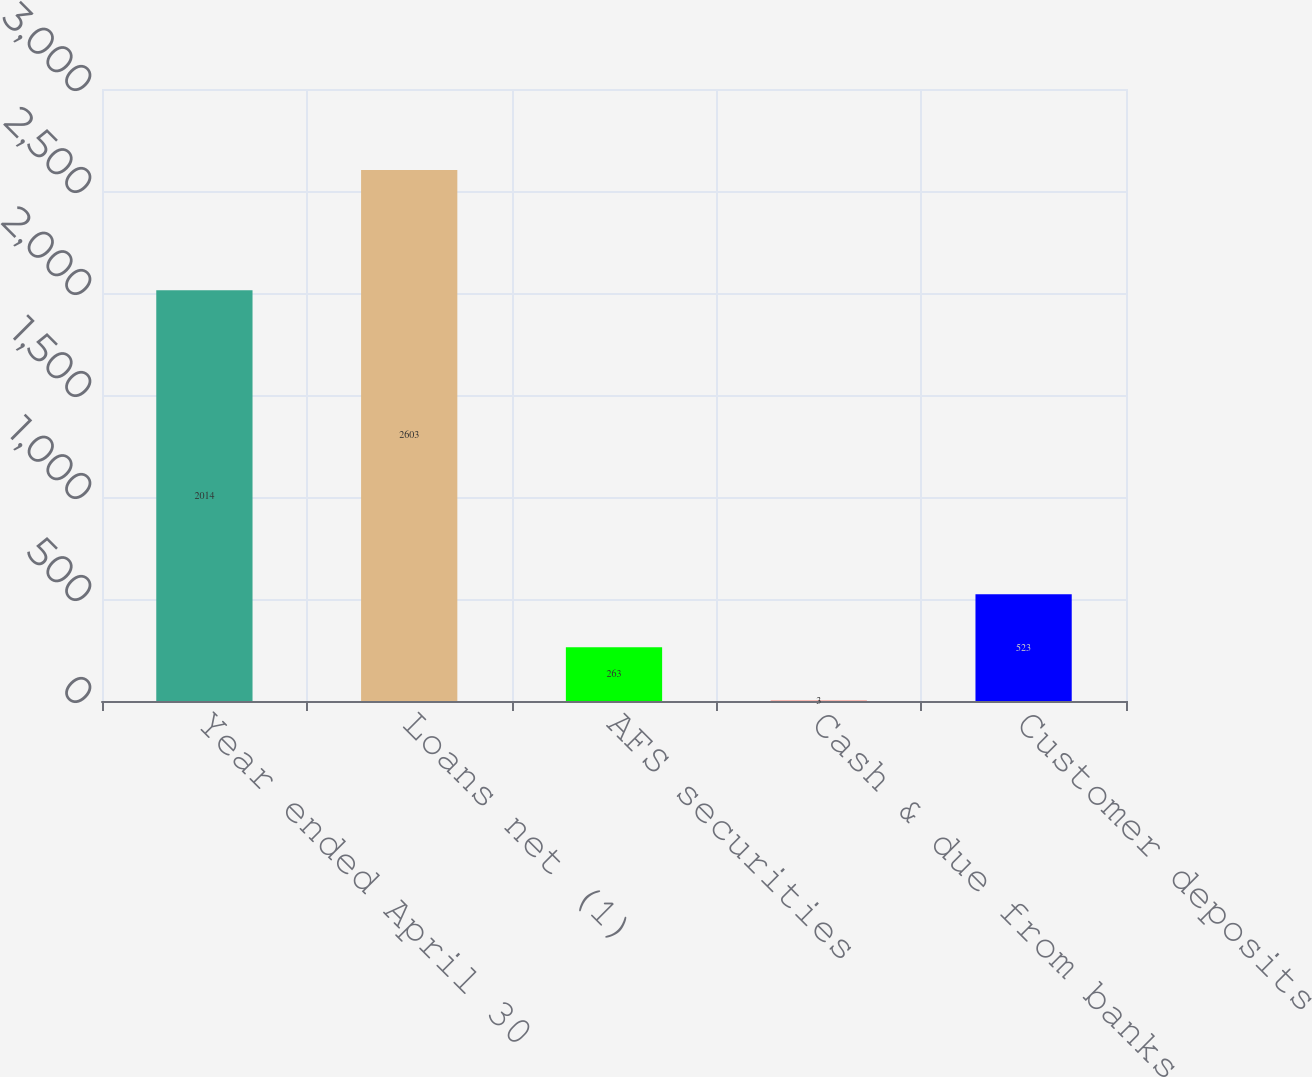Convert chart to OTSL. <chart><loc_0><loc_0><loc_500><loc_500><bar_chart><fcel>Year ended April 30<fcel>Loans net (1)<fcel>AFS securities<fcel>Cash & due from banks<fcel>Customer deposits<nl><fcel>2014<fcel>2603<fcel>263<fcel>3<fcel>523<nl></chart> 